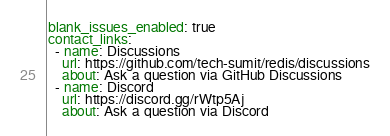<code> <loc_0><loc_0><loc_500><loc_500><_YAML_>blank_issues_enabled: true
contact_links:
  - name: Discussions
    url: https://github.com/tech-sumit/redis/discussions
    about: Ask a question via GitHub Discussions
  - name: Discord
    url: https://discord.gg/rWtp5Aj
    about: Ask a question via Discord
</code> 